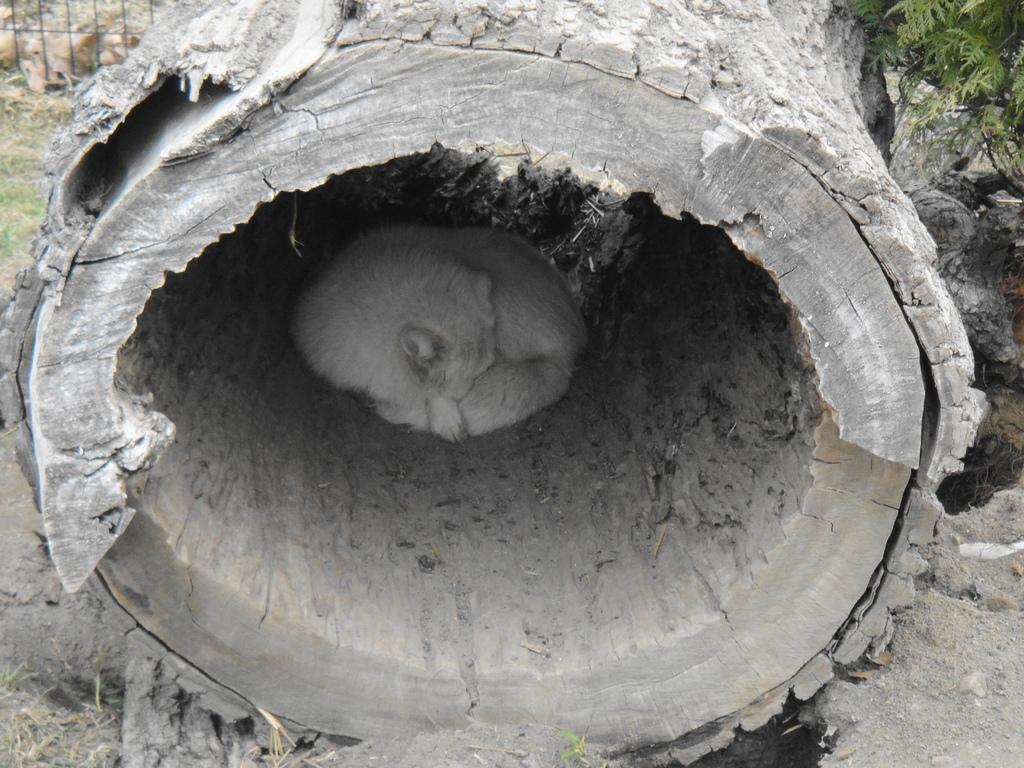What is the dog doing in the image? The dog is sitting inside a tree trunk in the image. What can be seen behind the dog? There is a fence at the back of the image. What type of vegetation is present in the image? There is a plant in the image, and there is also grass. What is visible at the bottom of the image? The ground is visible at the bottom of the image. What type of stone is the dog sitting on in the image? There is no stone present in the image; the dog is sitting inside a tree trunk. What kind of art can be seen on the fence in the image? There is no art visible on the fence in the image; it is a plain fence. 